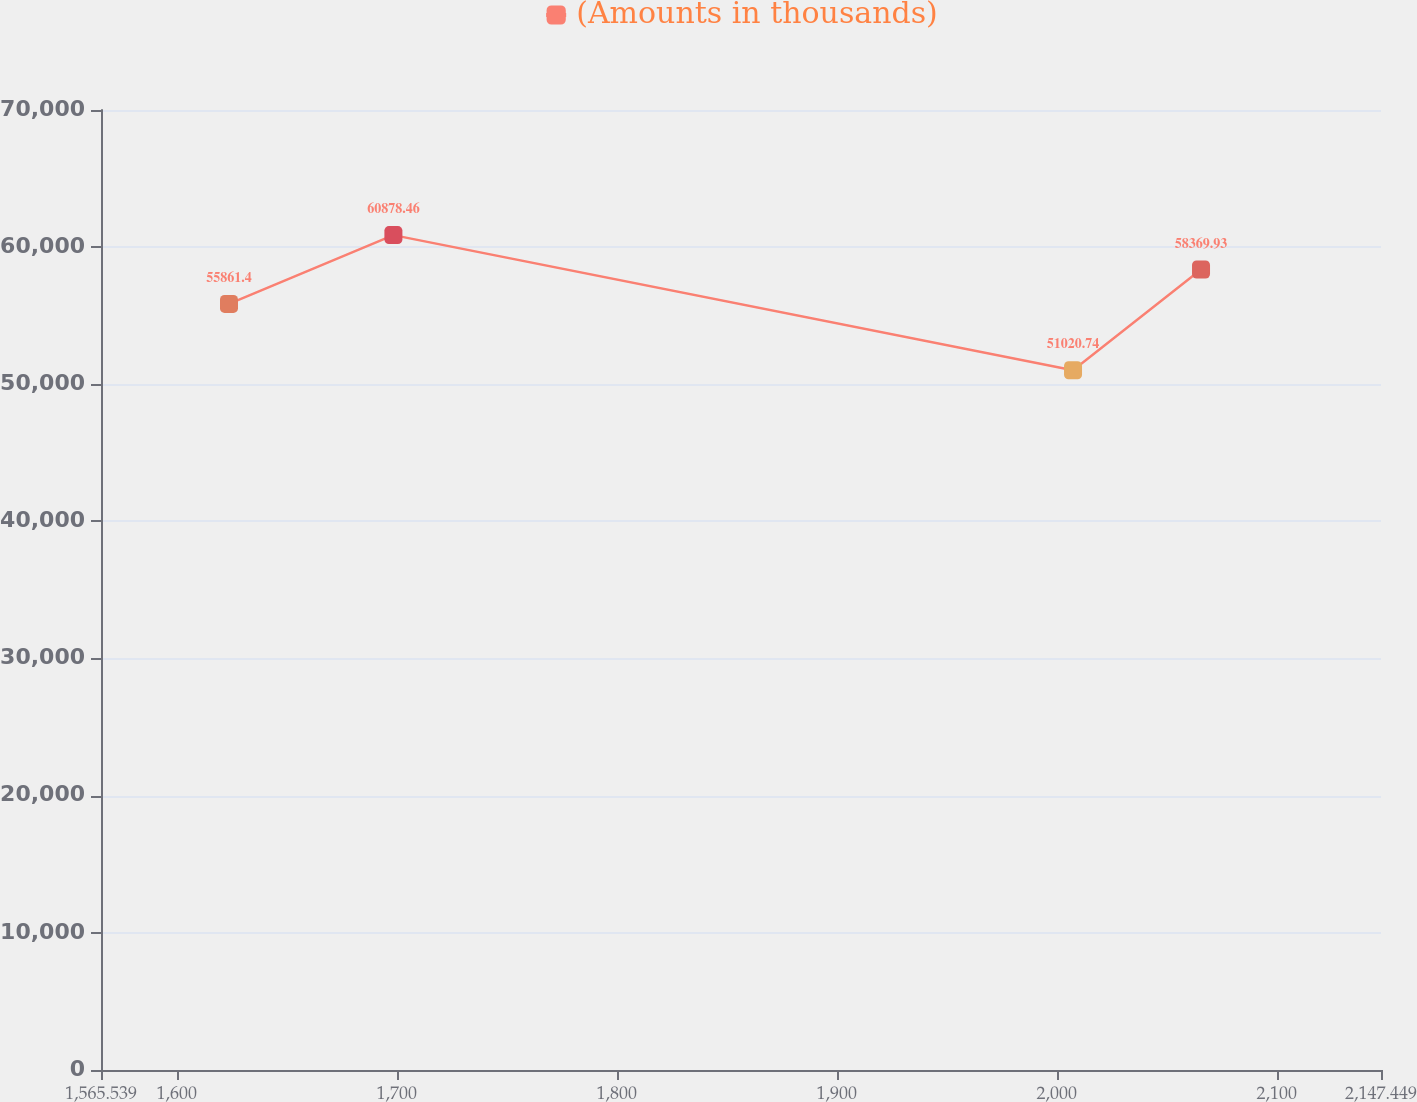<chart> <loc_0><loc_0><loc_500><loc_500><line_chart><ecel><fcel>(Amounts in thousands)<nl><fcel>1623.73<fcel>55861.4<nl><fcel>1698.47<fcel>60878.5<nl><fcel>2007.44<fcel>51020.7<nl><fcel>2065.63<fcel>58369.9<nl><fcel>2205.64<fcel>35006.3<nl></chart> 